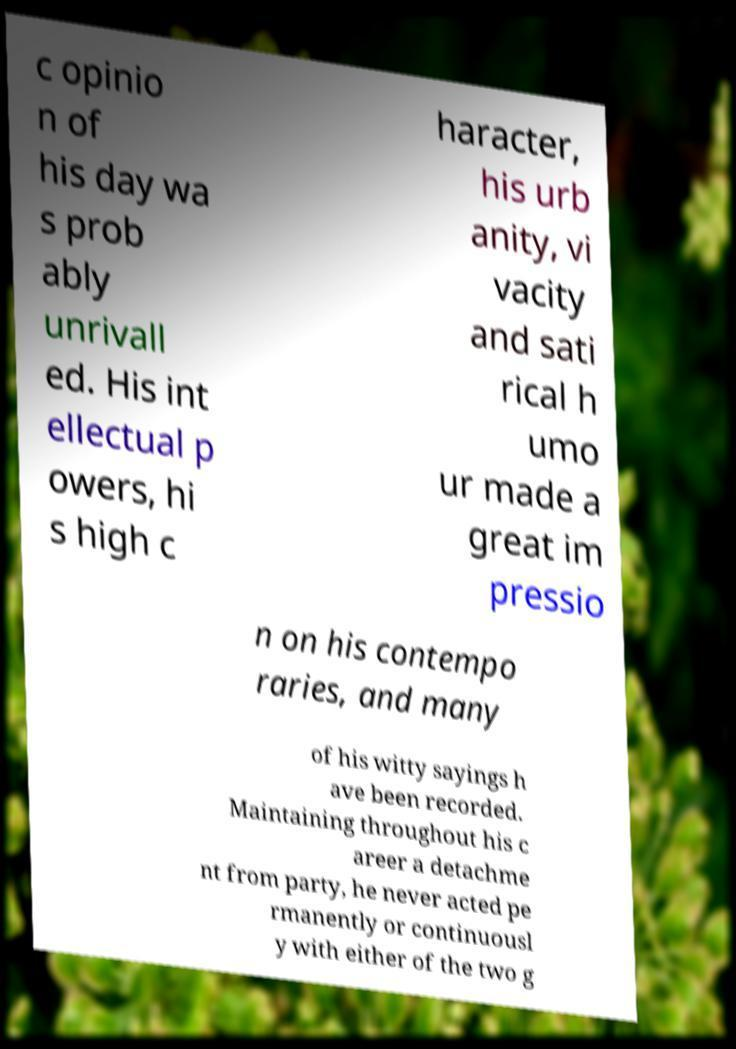Please read and relay the text visible in this image. What does it say? c opinio n of his day wa s prob ably unrivall ed. His int ellectual p owers, hi s high c haracter, his urb anity, vi vacity and sati rical h umo ur made a great im pressio n on his contempo raries, and many of his witty sayings h ave been recorded. Maintaining throughout his c areer a detachme nt from party, he never acted pe rmanently or continuousl y with either of the two g 